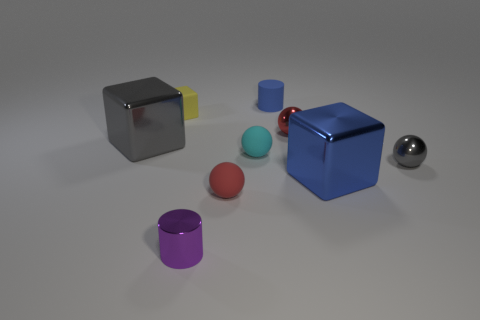Can you tell me the different colors visible in this image? In the image, you can see objects in several colors including gray, yellow, red, pink, blue, cyan, and a shade of dark metal or silver. 